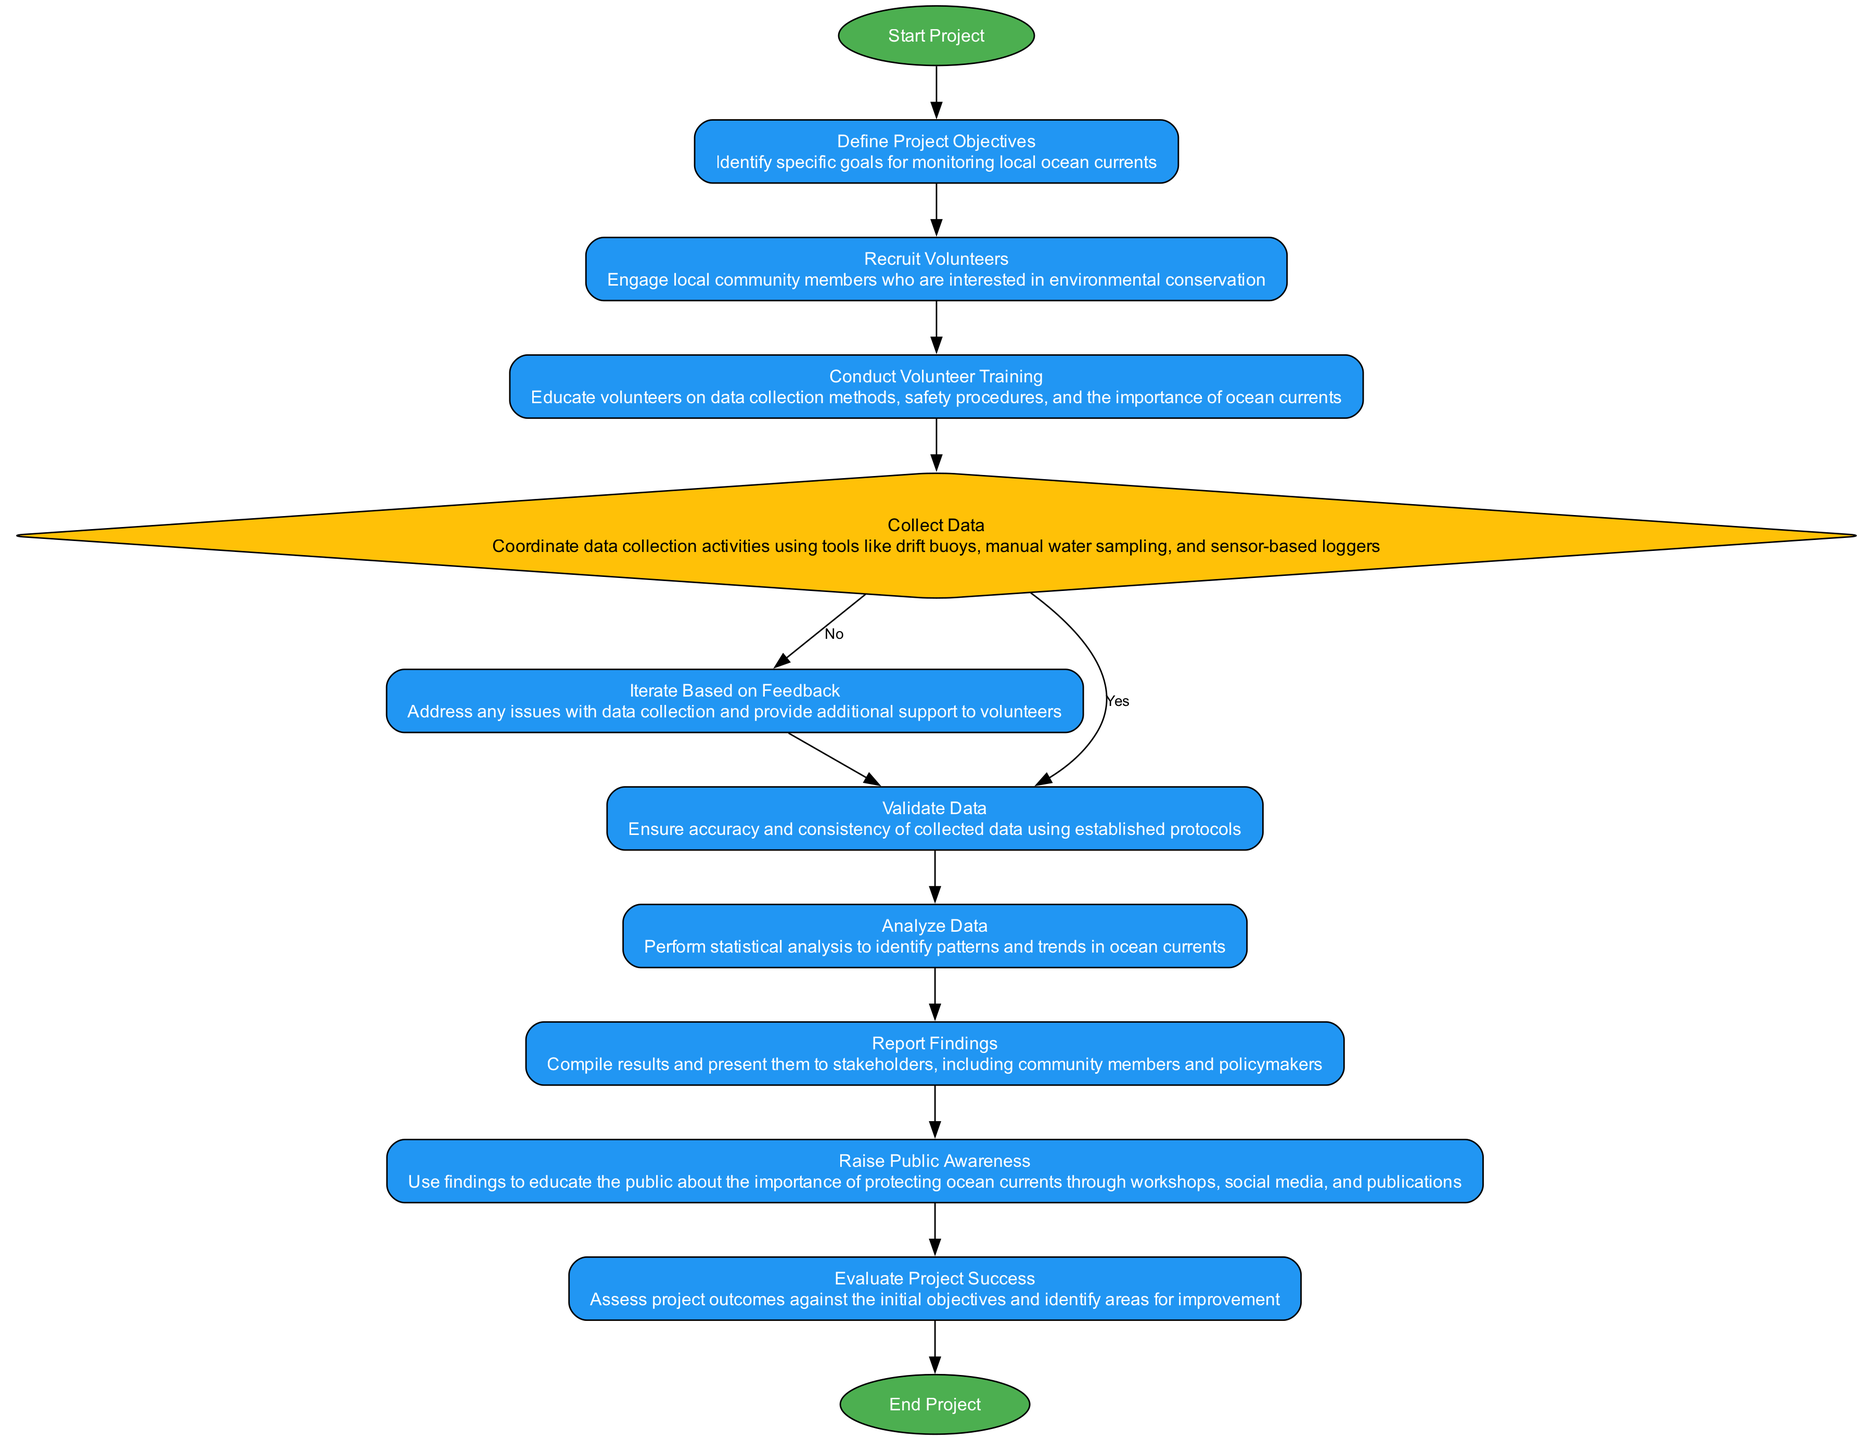What is the first step in the workflow? The diagram indicates that the first step is labeled "Start Project." This is the initial node in the flowchart and represents where the process begins.
Answer: Start Project How many process nodes are in the diagram? Counting the nodes labeled as "process" in the diagram: Define Project Objectives, Recruit Volunteers, Conduct Volunteer Training, Iterate Based on Feedback, Validate Data, Analyze Data, Report Findings, Raise Public Awareness, and Evaluate Project Success gives a total of 9 process nodes.
Answer: 9 What is the last step in the workflow? The last step in the flowchart is labeled "End Project." This node signifies the conclusion of the project workflow.
Answer: End Project Which node follows "Collect Data" if the answer is 'No'? According to the diagram, if the answer to "Collect Data" is 'No', the next node in the workflow is "Iterate Based on Feedback." This is indicated by the option provided in the decision node.
Answer: Iterate Based on Feedback What action is performed after validating data? Following the "Validate Data" process node, the next action in the workflow is "Analyze Data." This shows the sequence of steps that occur after ensuring data accuracy.
Answer: Analyze Data Which type of node comes after "Recruit Volunteers"? The node that follows "Recruit Volunteers" is "Conduct Volunteer Training." This indicates a direct progression from recruiting to training volunteers.
Answer: Conduct Volunteer Training What two outcomes can result from the "Collect Data" decision node? The two outcomes from the "Collect Data" decision node are 'Yes' and 'No', indicating whether data collection occurs or not. These options guide the subsequent steps based on the decision made.
Answer: Yes and No How do you move from "Report Findings" in the workflow? After "Report Findings," the workflow proceeds to "Raise Public Awareness." This is the subsequent step that informs the community about the findings.
Answer: Raise Public Awareness What is the color of the "decision" node? The "decision" node in the diagram is colored #FFC107, as indicated in the custom color palette provided for the flowchart elements.
Answer: #FFC107 